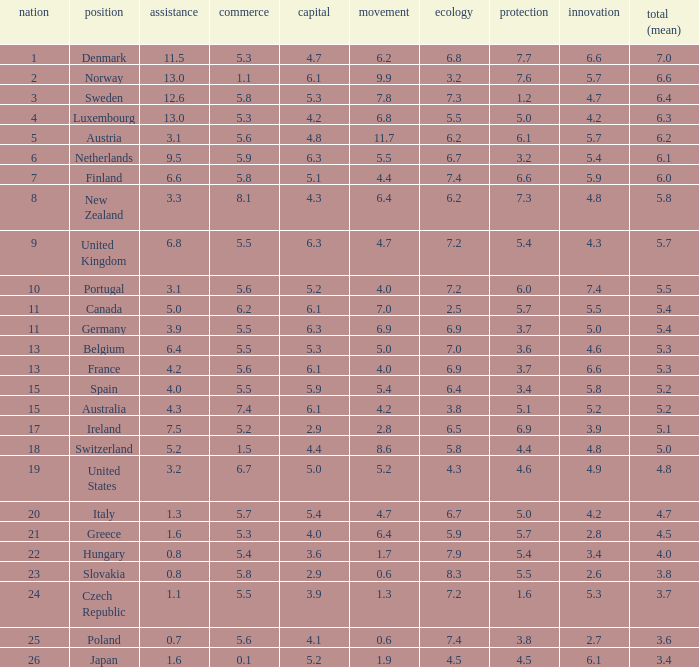What country has a 5.5 mark for security? Slovakia. 